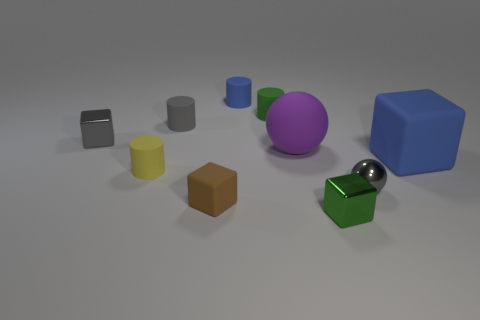How many objects are either gray spheres or tiny red rubber blocks?
Provide a succinct answer. 1. There is a green metal object that is the same size as the gray cube; what shape is it?
Ensure brevity in your answer.  Cube. How many things are on the right side of the gray block and in front of the green matte cylinder?
Provide a short and direct response. 7. There is a brown block that is to the left of the small green rubber cylinder; what is its material?
Provide a succinct answer. Rubber. There is a gray object that is the same material as the tiny brown thing; what size is it?
Ensure brevity in your answer.  Small. Do the blue matte thing that is behind the blue matte block and the gray metal cube that is behind the purple matte sphere have the same size?
Offer a very short reply. Yes. There is a ball that is the same size as the green metal block; what material is it?
Your answer should be very brief. Metal. There is a block that is left of the tiny green matte object and to the right of the gray matte object; what material is it?
Keep it short and to the point. Rubber. Are there any brown shiny objects?
Your answer should be very brief. No. Is the color of the small matte block the same as the metallic block left of the brown rubber object?
Ensure brevity in your answer.  No. 